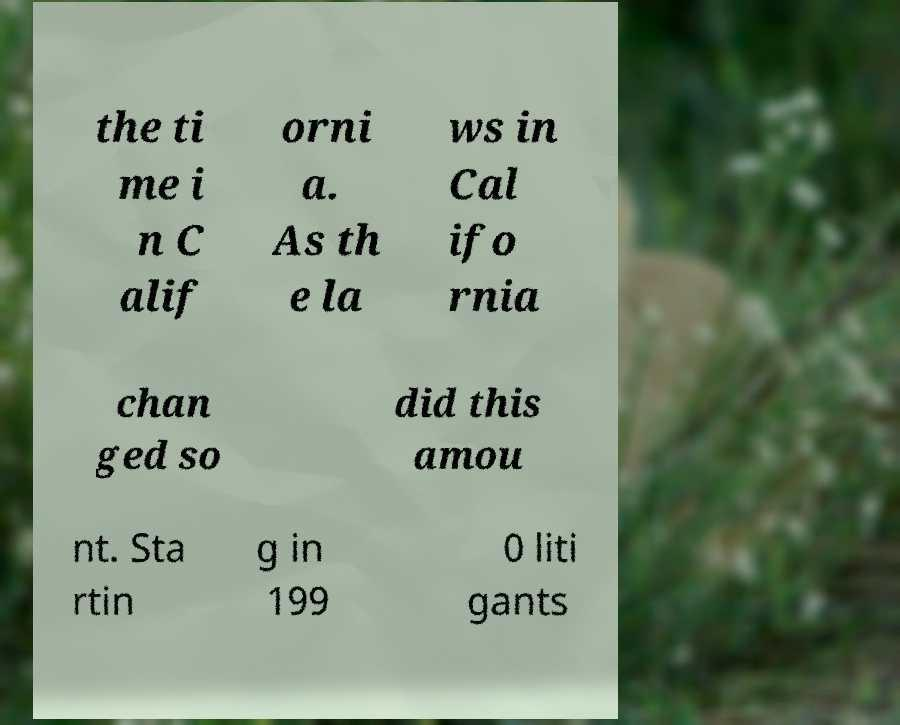I need the written content from this picture converted into text. Can you do that? the ti me i n C alif orni a. As th e la ws in Cal ifo rnia chan ged so did this amou nt. Sta rtin g in 199 0 liti gants 